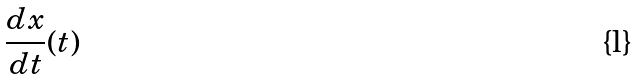<formula> <loc_0><loc_0><loc_500><loc_500>\frac { d x } { d t } ( t )</formula> 